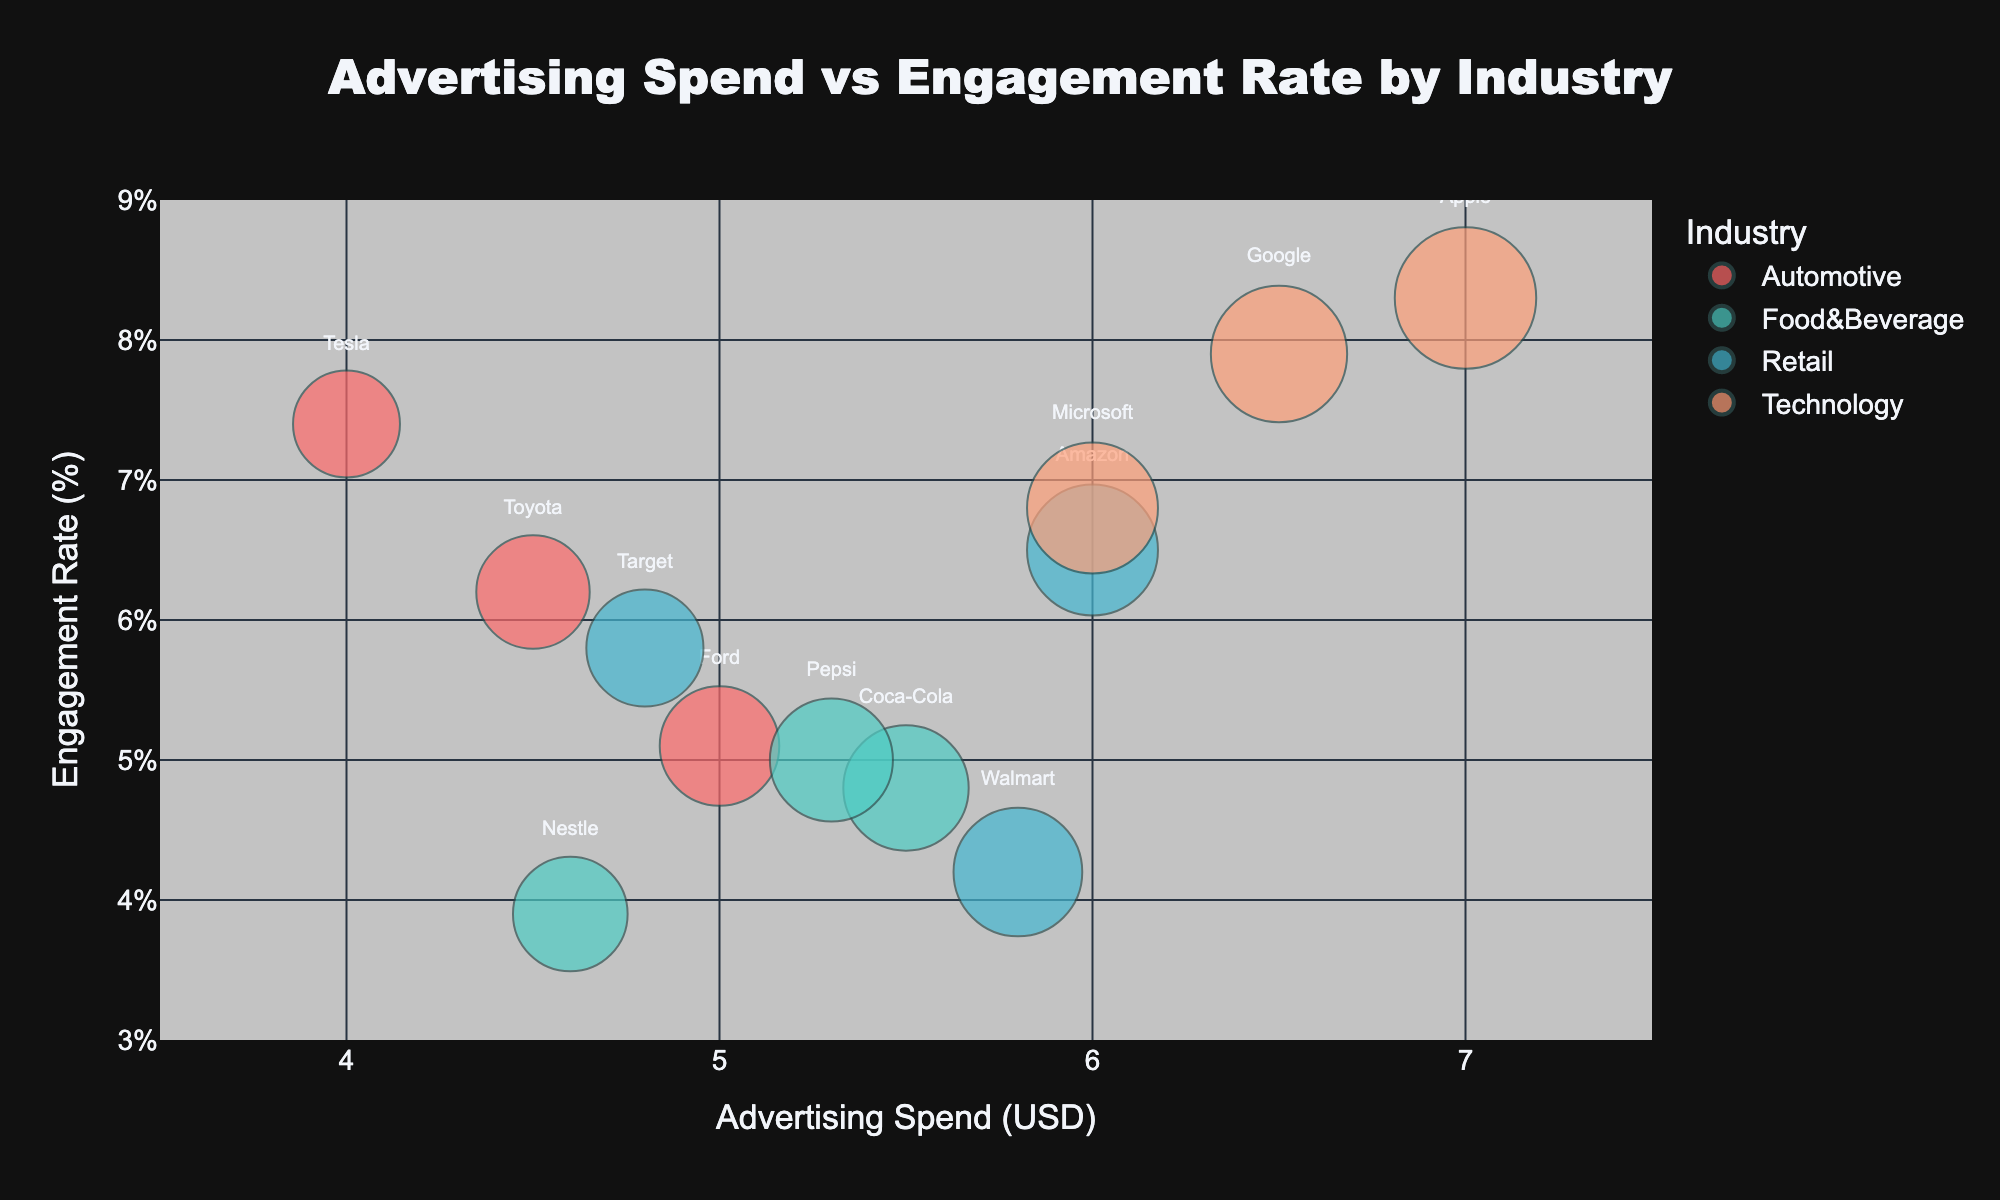What is the overall title of the chart? The title of the chart is usually displayed prominently at the top of the chart. In this case, it is specified in the title section of the layout update in the code.
Answer: Advertising Spend vs Engagement Rate by Industry Which industry has the highest engagement rate and which company is it associated with? The highest engagement rate can be observed from the chart by looking for the bubble that reaches the highest point on the y-axis. The hover name would reveal the company.
Answer: Technology, Apple What is the engagement rate for Amazon, and how does it compare to Walmart? Locate the bubbles for Amazon and Walmart by their labels, and compare their respective positions on the y-axis. Amazon's bubble is higher than Walmart's.
Answer: Amazon: 6.5%, Walmart: 4.2% Which industry has the most companies represented in the chart? Counting the distinct colors and the number of bubbles for each will show the number of companies per industry.
Answer: Retail What is the difference in advertising spend between the top spender and the lowest spender in the chart? The advertising spends are compared by looking at the x-axis values from the rightmost bubble (Apple) to the leftmost bubble (Tesla).
Answer: $3,000,000 Which company in the Automotive industry has the highest engagement rate, and what is that rate? The engagement rates can be compared within the Automotive industry by identifying the color corresponding to Automotive and finding the highest y-value among them.
Answer: Tesla, 7.4% What’s the range of engagement rates for companies within the Food & Beverage industry? Identify bubbles belonging to the Food & Beverage industry and observe the lowest and highest positions on the y-axis.
Answer: 3.9% to 5.0% What is the average advertising spend for the Technology industry? Add the advertising spends of Apple, Google, and Microsoft, then divide by 3 to find the average.
Answer: (7000000 + 6500000 + 6000000) / 3 = $6,500,000 Are there any industries where all companies have an engagement rate below 5%? Checking each bubble’s position for each industry and comparing their heights on the y-axis to see if any industry has all its points below the 5% line.
Answer: Food & Beverage Which company’s bubble size is the largest on the chart? The size of the bubble directly corresponds to the advertising spend, so the largest bubble will be Apple, as it has the highest advertising spend.
Answer: Apple 